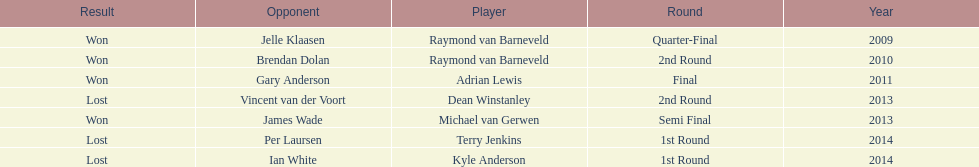Other than kyle anderson, who else lost in 2014? Terry Jenkins. I'm looking to parse the entire table for insights. Could you assist me with that? {'header': ['Result', 'Opponent', 'Player', 'Round', 'Year'], 'rows': [['Won', 'Jelle Klaasen', 'Raymond van Barneveld', 'Quarter-Final', '2009'], ['Won', 'Brendan Dolan', 'Raymond van Barneveld', '2nd Round', '2010'], ['Won', 'Gary Anderson', 'Adrian Lewis', 'Final', '2011'], ['Lost', 'Vincent van der Voort', 'Dean Winstanley', '2nd Round', '2013'], ['Won', 'James Wade', 'Michael van Gerwen', 'Semi Final', '2013'], ['Lost', 'Per Laursen', 'Terry Jenkins', '1st Round', '2014'], ['Lost', 'Ian White', 'Kyle Anderson', '1st Round', '2014']]} 